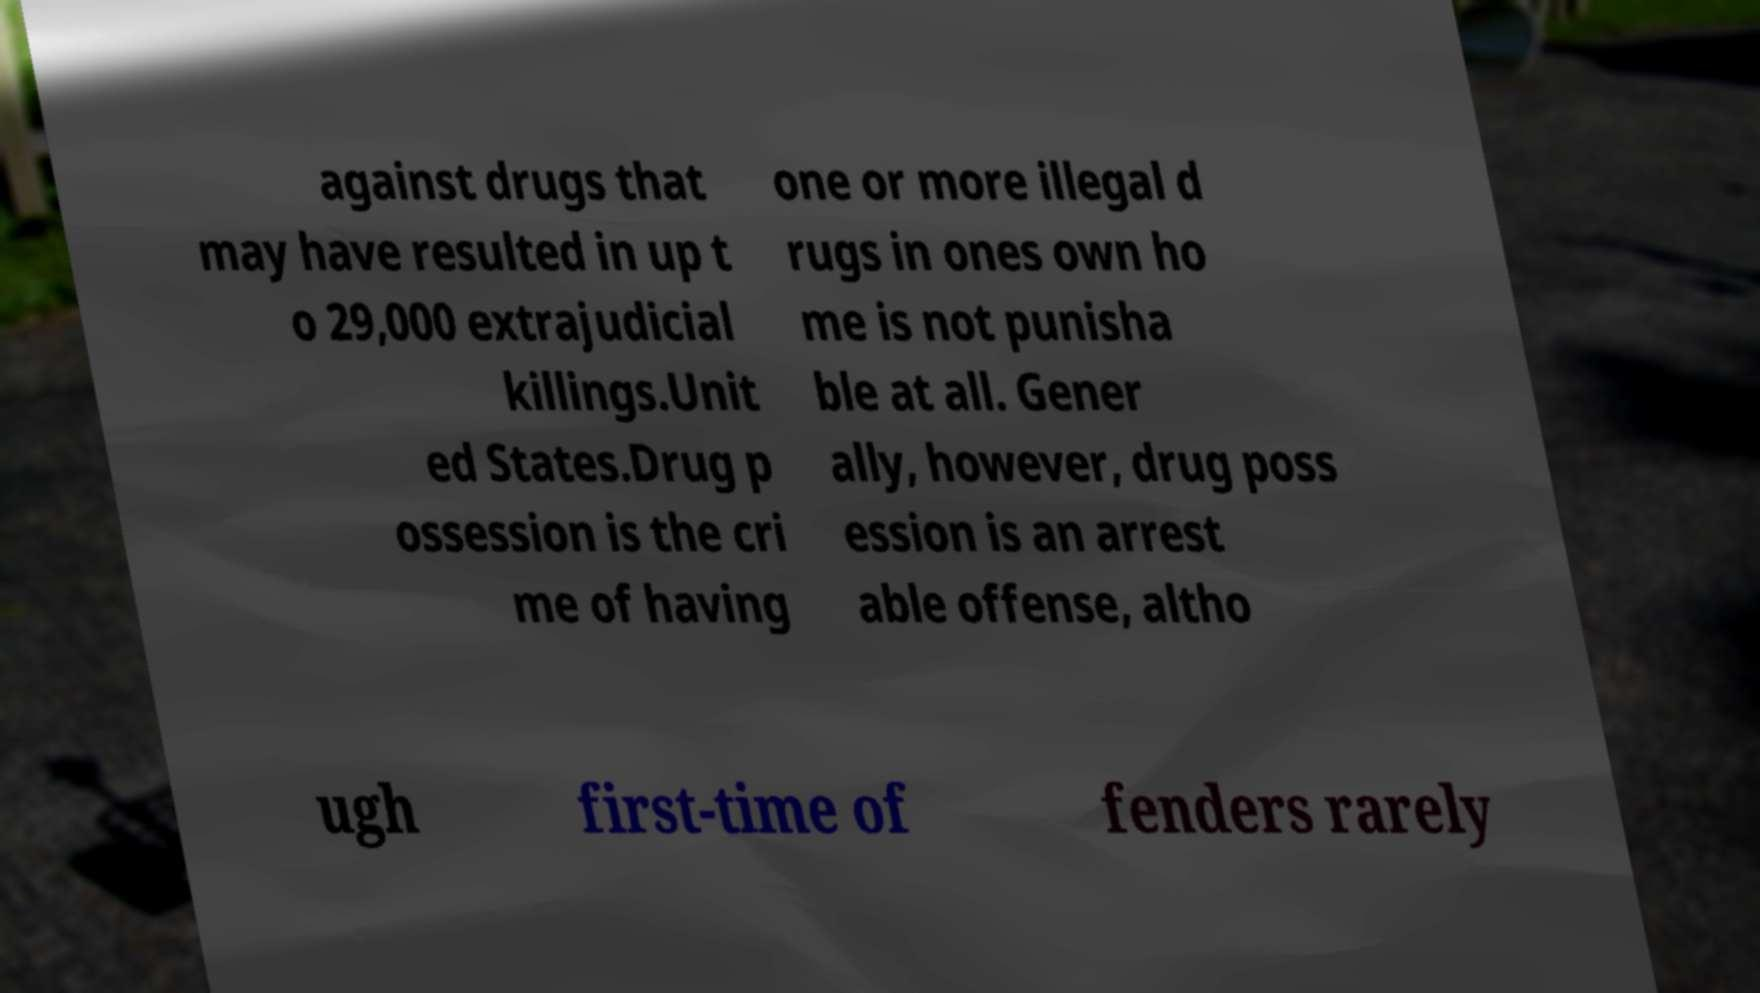Please identify and transcribe the text found in this image. against drugs that may have resulted in up t o 29,000 extrajudicial killings.Unit ed States.Drug p ossession is the cri me of having one or more illegal d rugs in ones own ho me is not punisha ble at all. Gener ally, however, drug poss ession is an arrest able offense, altho ugh first-time of fenders rarely 